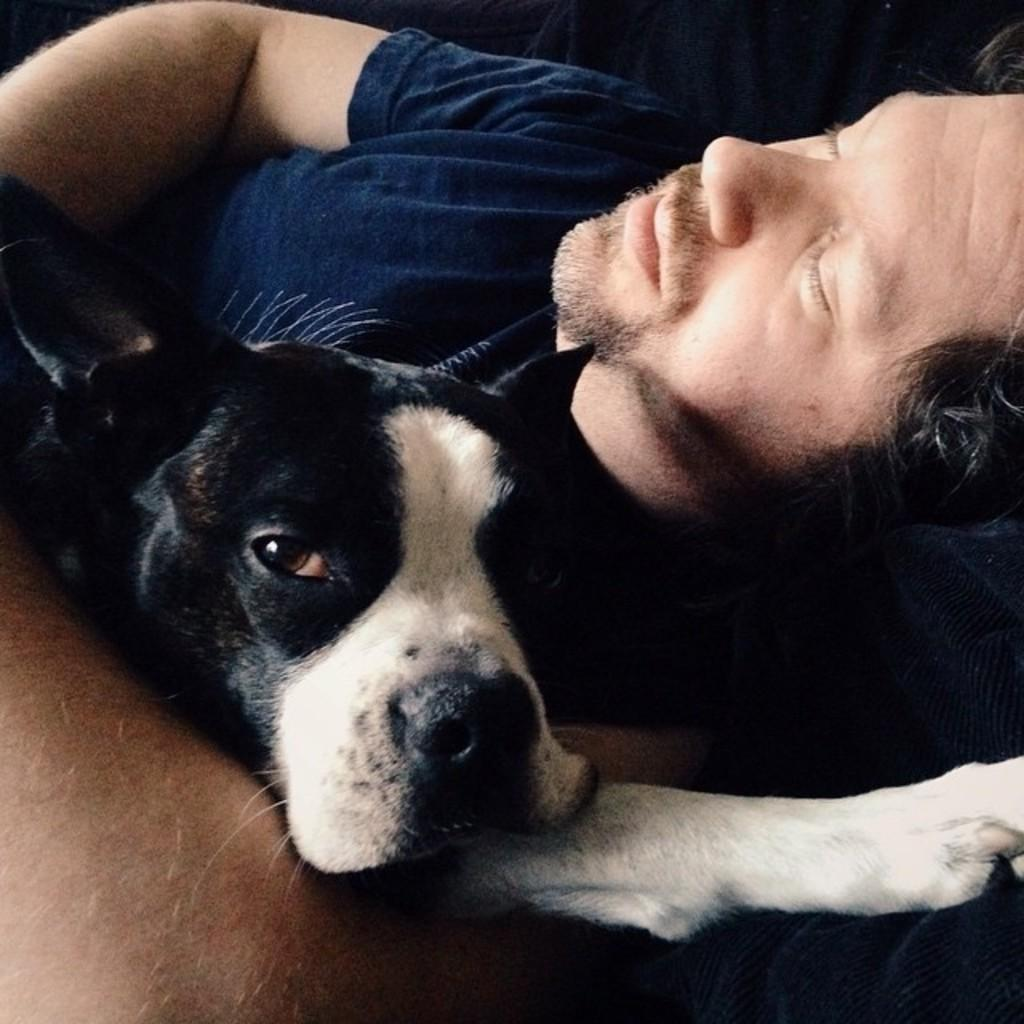Who is present in the image? There is a guy in the image. What is the guy doing in the image? The guy is sleeping on a sofa. Is there any other living creature in the image? Yes, there is a dog in the image. How is the dog positioned in relation to the guy? The dog is in the guy's hand. What type of jewel is the guy wearing on his finger in the image? There is no mention of a jewel in the image; the guy is simply sleeping on a sofa with a dog in his hand. 